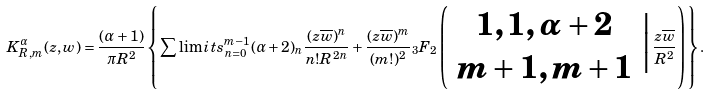<formula> <loc_0><loc_0><loc_500><loc_500>K ^ { \alpha } _ { R , m } ( z , w ) = \frac { ( \alpha + 1 ) } { \pi R ^ { 2 } } \left \{ \sum \lim i t s _ { n = 0 } ^ { m - 1 } ( \alpha + 2 ) _ { n } \frac { ( z \overline { w } ) ^ { n } } { n ! R ^ { 2 n } } + \frac { ( z \overline { w } ) ^ { m } } { ( m ! ) ^ { 2 } } { _ { 3 } F _ { 2 } } \left ( \begin{array} { c } 1 , 1 , \alpha + 2 \\ m + 1 , m + 1 \end{array} \Big | \frac { z \overline { w } } { R ^ { 2 } } \right ) \right \} .</formula> 